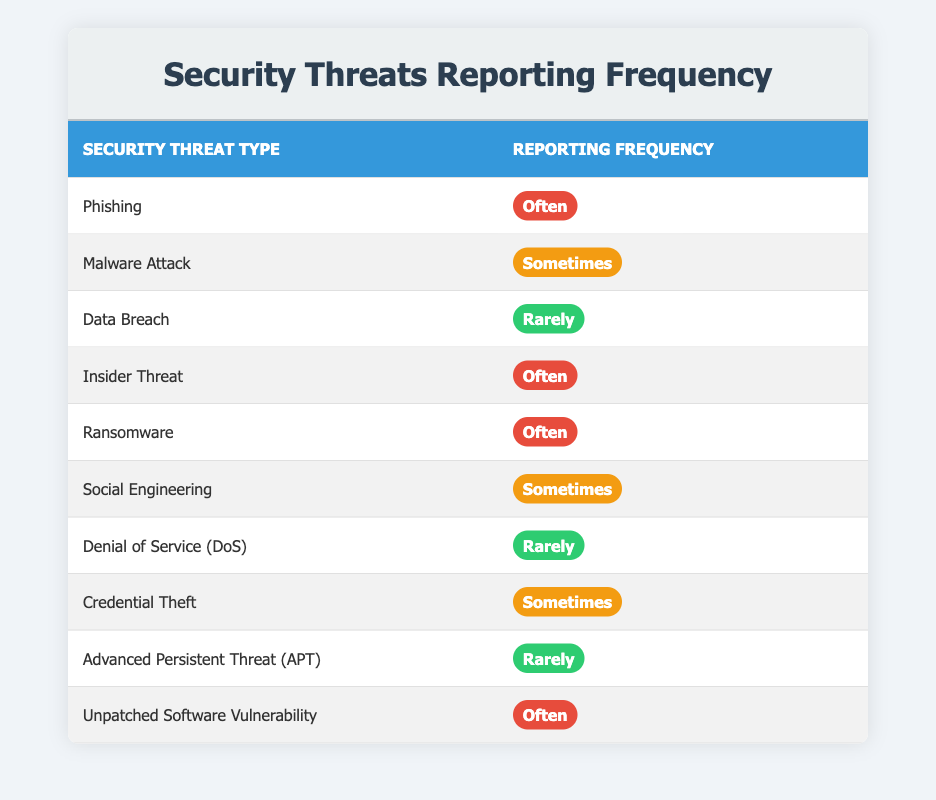What is the reporting frequency for Phishing? The table lists "Phishing" in the first row. The corresponding reporting frequency next to it is "Often."
Answer: Often How many types of security threats are reported sometimes? By scanning the table, we find three threats with the reporting frequency of "Sometimes": Malware Attack, Social Engineering, and Credential Theft. Hence, there are three types.
Answer: 3 Is Ransomware reported often? The entry in the table for Ransomware shows the reporting frequency as "Often." Therefore, the statement is true.
Answer: Yes Which security threat has the same reporting frequency as Credential Theft? The table shows that Credential Theft, like Social Engineering, is reported "Sometimes." Thus, these two threats share the same reporting frequency.
Answer: Social Engineering What is the total number of security threats reported often? The table lists five threats under the reporting frequency of "Often": Phishing, Insider Threat, Ransomware, Unpatched Software Vulnerability, and two more threats. Counting them gives a total of five.
Answer: 5 Which threats are reported rarely? From the table, the threats that have a reporting frequency of "Rarely" are Data Breach, Denial of Service (DoS), and Advanced Persistent Threat (APT). Thus, three threats are reported rarely.
Answer: 3 Is there a threat that has a higher frequency than "Sometimes"? "Often" is a higher frequency than "Sometimes," and threats like Phishing, Insider Threat, Ransomware, and Unpatched Software Vulnerability are recorded under "Often." So yes, there are threats with a higher reporting frequency.
Answer: Yes How frequently is Data Breach reported compared to Malware Attack? The table indicates that Data Breach is reported "Rarely," while Malware Attack is reported "Sometimes." Since "Sometimes" indicates more frequent reporting than "Rarely," it shows that Malware Attack is reported more frequently than Data Breach.
Answer: Sometimes Which reporting frequency appears the least in the table? There are four instances of "Rarely" (Data Breach, Denial of Service, Advanced Persistent Threat) in the table compared to five "Often" and three "Sometimes" labels. Hence, "Rarely" appears the least.
Answer: Rarely 